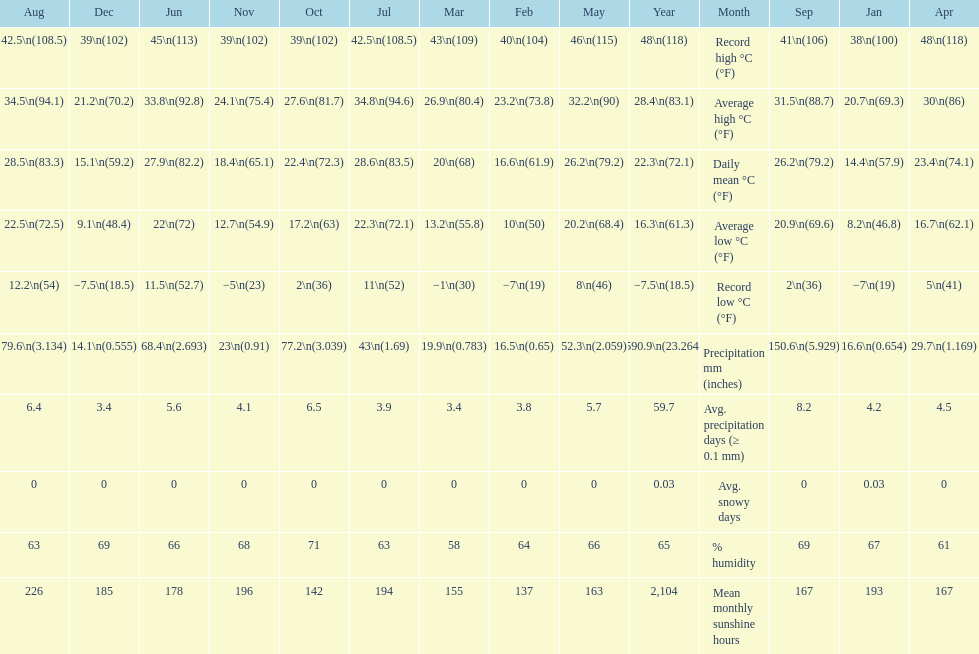Was there more precipitation in march or april? April. Help me parse the entirety of this table. {'header': ['Aug', 'Dec', 'Jun', 'Nov', 'Oct', 'Jul', 'Mar', 'Feb', 'May', 'Year', 'Month', 'Sep', 'Jan', 'Apr'], 'rows': [['42.5\\n(108.5)', '39\\n(102)', '45\\n(113)', '39\\n(102)', '39\\n(102)', '42.5\\n(108.5)', '43\\n(109)', '40\\n(104)', '46\\n(115)', '48\\n(118)', 'Record high °C (°F)', '41\\n(106)', '38\\n(100)', '48\\n(118)'], ['34.5\\n(94.1)', '21.2\\n(70.2)', '33.8\\n(92.8)', '24.1\\n(75.4)', '27.6\\n(81.7)', '34.8\\n(94.6)', '26.9\\n(80.4)', '23.2\\n(73.8)', '32.2\\n(90)', '28.4\\n(83.1)', 'Average high °C (°F)', '31.5\\n(88.7)', '20.7\\n(69.3)', '30\\n(86)'], ['28.5\\n(83.3)', '15.1\\n(59.2)', '27.9\\n(82.2)', '18.4\\n(65.1)', '22.4\\n(72.3)', '28.6\\n(83.5)', '20\\n(68)', '16.6\\n(61.9)', '26.2\\n(79.2)', '22.3\\n(72.1)', 'Daily mean °C (°F)', '26.2\\n(79.2)', '14.4\\n(57.9)', '23.4\\n(74.1)'], ['22.5\\n(72.5)', '9.1\\n(48.4)', '22\\n(72)', '12.7\\n(54.9)', '17.2\\n(63)', '22.3\\n(72.1)', '13.2\\n(55.8)', '10\\n(50)', '20.2\\n(68.4)', '16.3\\n(61.3)', 'Average low °C (°F)', '20.9\\n(69.6)', '8.2\\n(46.8)', '16.7\\n(62.1)'], ['12.2\\n(54)', '−7.5\\n(18.5)', '11.5\\n(52.7)', '−5\\n(23)', '2\\n(36)', '11\\n(52)', '−1\\n(30)', '−7\\n(19)', '8\\n(46)', '−7.5\\n(18.5)', 'Record low °C (°F)', '2\\n(36)', '−7\\n(19)', '5\\n(41)'], ['79.6\\n(3.134)', '14.1\\n(0.555)', '68.4\\n(2.693)', '23\\n(0.91)', '77.2\\n(3.039)', '43\\n(1.69)', '19.9\\n(0.783)', '16.5\\n(0.65)', '52.3\\n(2.059)', '590.9\\n(23.264)', 'Precipitation mm (inches)', '150.6\\n(5.929)', '16.6\\n(0.654)', '29.7\\n(1.169)'], ['6.4', '3.4', '5.6', '4.1', '6.5', '3.9', '3.4', '3.8', '5.7', '59.7', 'Avg. precipitation days (≥ 0.1 mm)', '8.2', '4.2', '4.5'], ['0', '0', '0', '0', '0', '0', '0', '0', '0', '0.03', 'Avg. snowy days', '0', '0.03', '0'], ['63', '69', '66', '68', '71', '63', '58', '64', '66', '65', '% humidity', '69', '67', '61'], ['226', '185', '178', '196', '142', '194', '155', '137', '163', '2,104', 'Mean monthly sunshine hours', '167', '193', '167']]} 